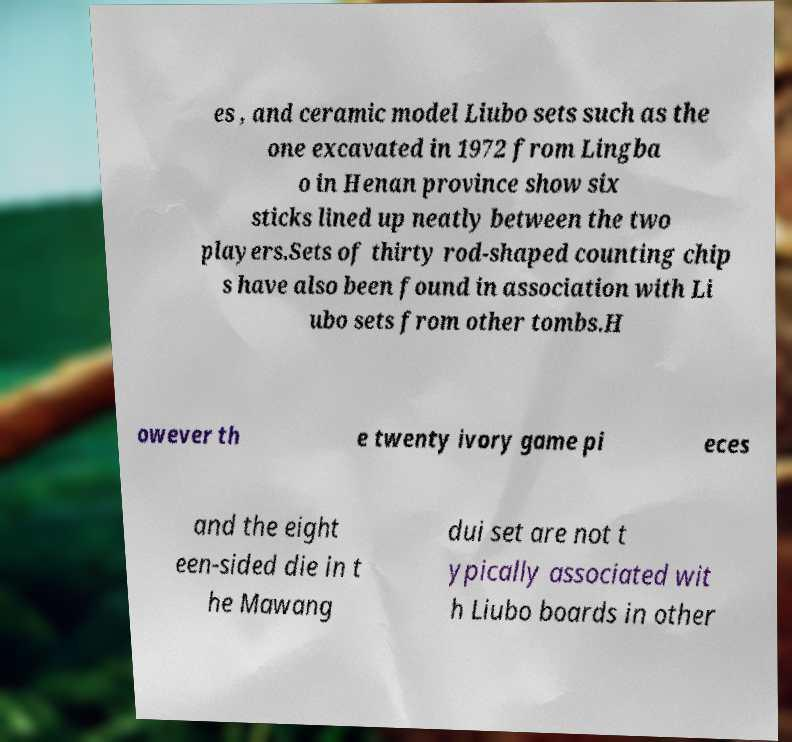There's text embedded in this image that I need extracted. Can you transcribe it verbatim? es , and ceramic model Liubo sets such as the one excavated in 1972 from Lingba o in Henan province show six sticks lined up neatly between the two players.Sets of thirty rod-shaped counting chip s have also been found in association with Li ubo sets from other tombs.H owever th e twenty ivory game pi eces and the eight een-sided die in t he Mawang dui set are not t ypically associated wit h Liubo boards in other 